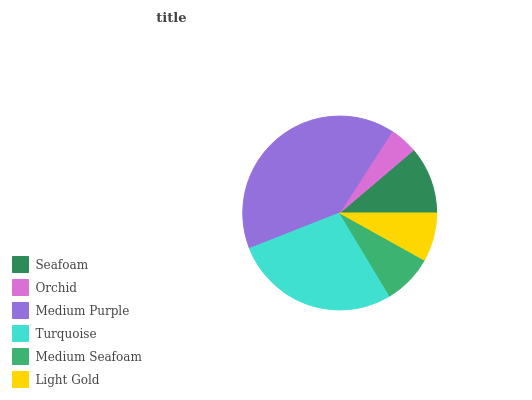Is Orchid the minimum?
Answer yes or no. Yes. Is Medium Purple the maximum?
Answer yes or no. Yes. Is Medium Purple the minimum?
Answer yes or no. No. Is Orchid the maximum?
Answer yes or no. No. Is Medium Purple greater than Orchid?
Answer yes or no. Yes. Is Orchid less than Medium Purple?
Answer yes or no. Yes. Is Orchid greater than Medium Purple?
Answer yes or no. No. Is Medium Purple less than Orchid?
Answer yes or no. No. Is Seafoam the high median?
Answer yes or no. Yes. Is Medium Seafoam the low median?
Answer yes or no. Yes. Is Orchid the high median?
Answer yes or no. No. Is Light Gold the low median?
Answer yes or no. No. 